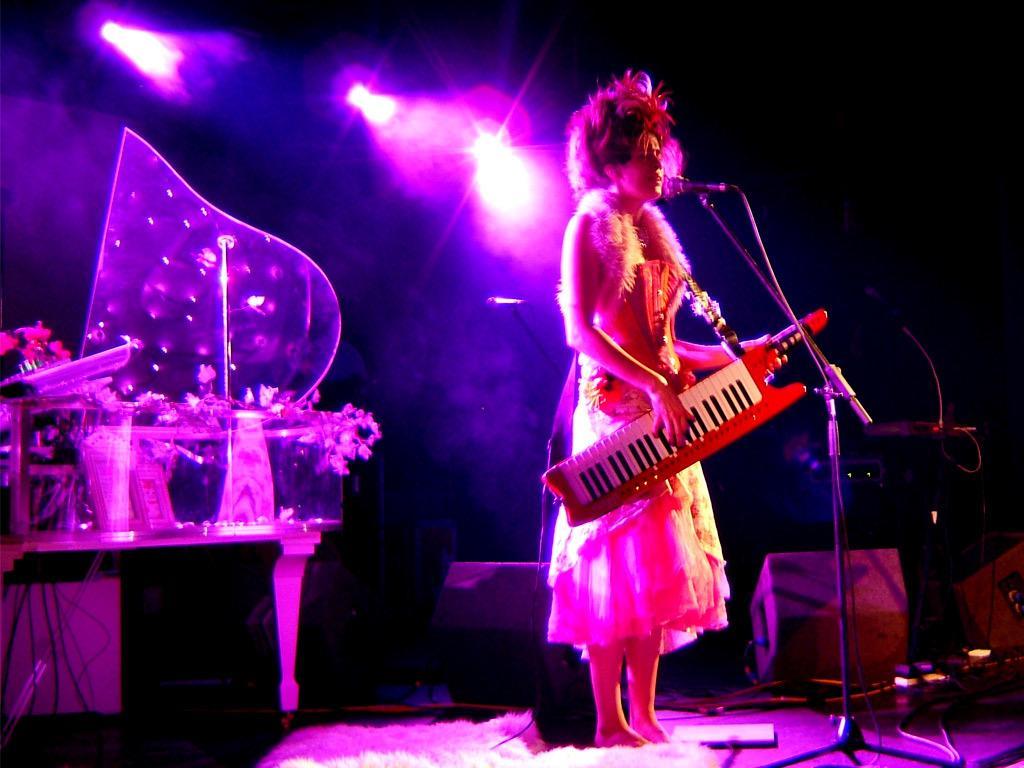Please provide a concise description of this image. In this image in the center there is one woman who is standing, and she is holding some musical instrument and it seems that she is singing. In front of her there is one mike, on the left side there are some flower bouquets and table and some other objects. In the background there are some speakers and lights and wires, at the bottom there are some other objects. 